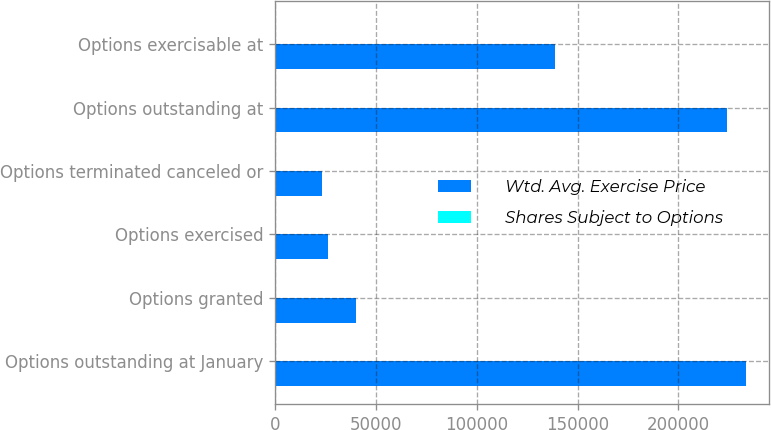<chart> <loc_0><loc_0><loc_500><loc_500><stacked_bar_chart><ecel><fcel>Options outstanding at January<fcel>Options granted<fcel>Options exercised<fcel>Options terminated canceled or<fcel>Options outstanding at<fcel>Options exercisable at<nl><fcel>Wtd. Avg. Exercise Price<fcel>233445<fcel>40257<fcel>26211<fcel>23236<fcel>224255<fcel>138741<nl><fcel>Shares Subject to Options<fcel>18<fcel>18<fcel>11<fcel>19<fcel>19<fcel>19<nl></chart> 